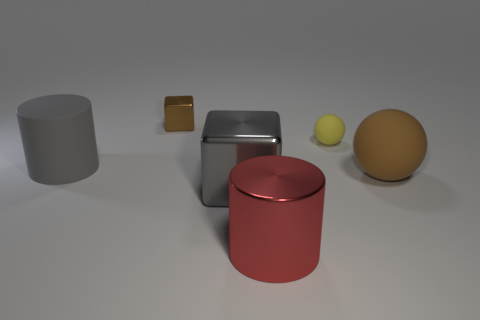Add 2 large metallic cylinders. How many objects exist? 8 Subtract all cylinders. How many objects are left? 4 Subtract all yellow matte spheres. Subtract all large metallic blocks. How many objects are left? 4 Add 3 big gray things. How many big gray things are left? 5 Add 4 tiny red things. How many tiny red things exist? 4 Subtract 0 purple blocks. How many objects are left? 6 